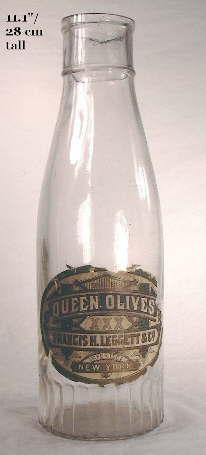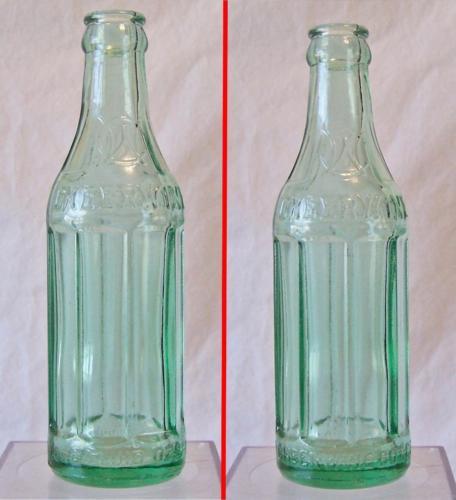The first image is the image on the left, the second image is the image on the right. Evaluate the accuracy of this statement regarding the images: "One image shows a single upright, uncapped clear bottle with a colored label and ridges around the glass, and the other image shows at least six varied glass bottles without colored labels.". Is it true? Answer yes or no. No. The first image is the image on the left, the second image is the image on the right. Given the left and right images, does the statement "The right image contains exactly one glass bottle." hold true? Answer yes or no. No. 